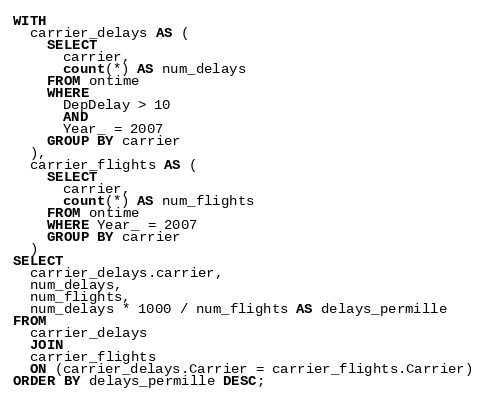<code> <loc_0><loc_0><loc_500><loc_500><_SQL_>WITH
  carrier_delays AS (
    SELECT
      carrier,
      count(*) AS num_delays
    FROM ontime
    WHERE
      DepDelay > 10
      AND
      Year_ = 2007
    GROUP BY carrier
  ),
  carrier_flights AS (
    SELECT
      carrier,
      count(*) AS num_flights
    FROM ontime
    WHERE Year_ = 2007
    GROUP BY carrier
  )
SELECT
  carrier_delays.carrier,
  num_delays,
  num_flights,
  num_delays * 1000 / num_flights AS delays_permille
FROM
  carrier_delays
  JOIN
  carrier_flights
  ON (carrier_delays.Carrier = carrier_flights.Carrier)
ORDER BY delays_permille DESC;
</code> 